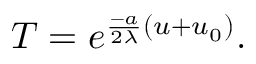Convert formula to latex. <formula><loc_0><loc_0><loc_500><loc_500>T = e ^ { \frac { - a } { 2 \lambda } ( u + u _ { 0 } ) } .</formula> 